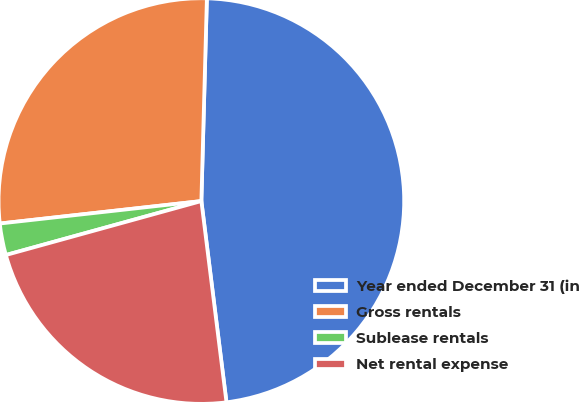Convert chart. <chart><loc_0><loc_0><loc_500><loc_500><pie_chart><fcel>Year ended December 31 (in<fcel>Gross rentals<fcel>Sublease rentals<fcel>Net rental expense<nl><fcel>47.59%<fcel>27.2%<fcel>2.52%<fcel>22.69%<nl></chart> 